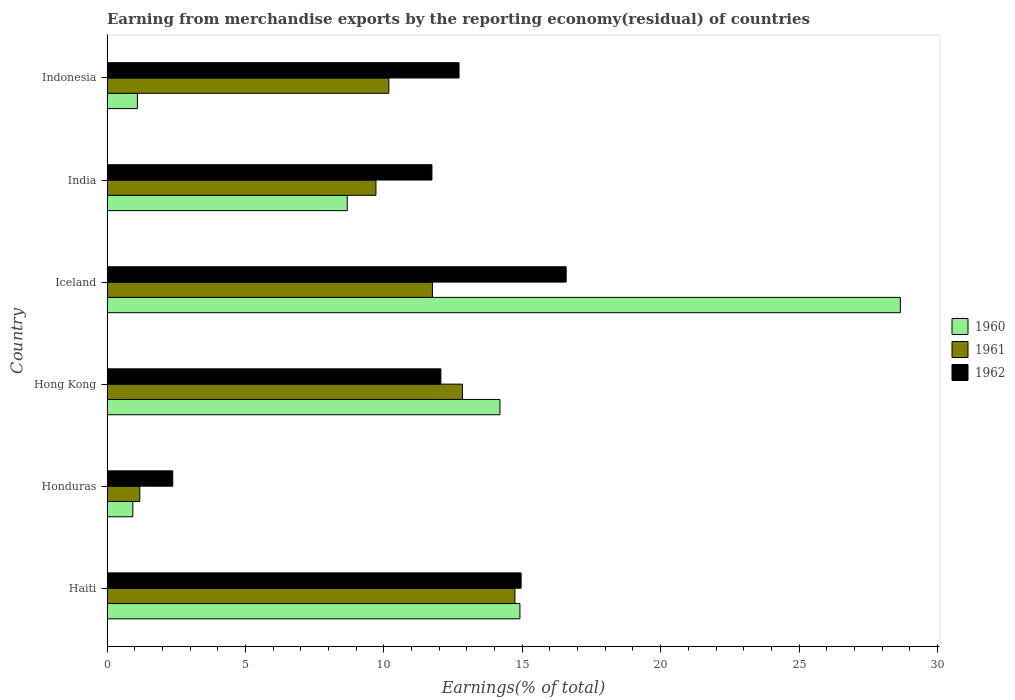How many different coloured bars are there?
Your answer should be compact. 3. Are the number of bars per tick equal to the number of legend labels?
Offer a very short reply. Yes. How many bars are there on the 2nd tick from the top?
Offer a very short reply. 3. How many bars are there on the 6th tick from the bottom?
Keep it short and to the point. 3. What is the label of the 1st group of bars from the top?
Provide a short and direct response. Indonesia. In how many cases, is the number of bars for a given country not equal to the number of legend labels?
Your answer should be very brief. 0. What is the percentage of amount earned from merchandise exports in 1961 in India?
Provide a short and direct response. 9.71. Across all countries, what is the maximum percentage of amount earned from merchandise exports in 1961?
Your answer should be very brief. 14.74. Across all countries, what is the minimum percentage of amount earned from merchandise exports in 1961?
Offer a very short reply. 1.19. In which country was the percentage of amount earned from merchandise exports in 1961 maximum?
Give a very brief answer. Haiti. In which country was the percentage of amount earned from merchandise exports in 1962 minimum?
Offer a terse response. Honduras. What is the total percentage of amount earned from merchandise exports in 1962 in the graph?
Your answer should be very brief. 70.44. What is the difference between the percentage of amount earned from merchandise exports in 1962 in Hong Kong and that in Iceland?
Offer a very short reply. -4.53. What is the difference between the percentage of amount earned from merchandise exports in 1960 in India and the percentage of amount earned from merchandise exports in 1962 in Honduras?
Provide a short and direct response. 6.3. What is the average percentage of amount earned from merchandise exports in 1961 per country?
Offer a terse response. 10.07. What is the difference between the percentage of amount earned from merchandise exports in 1961 and percentage of amount earned from merchandise exports in 1962 in Haiti?
Ensure brevity in your answer.  -0.22. In how many countries, is the percentage of amount earned from merchandise exports in 1961 greater than 27 %?
Offer a very short reply. 0. What is the ratio of the percentage of amount earned from merchandise exports in 1962 in Haiti to that in Indonesia?
Your answer should be compact. 1.18. Is the percentage of amount earned from merchandise exports in 1962 in Haiti less than that in Iceland?
Give a very brief answer. Yes. What is the difference between the highest and the second highest percentage of amount earned from merchandise exports in 1960?
Offer a terse response. 13.74. What is the difference between the highest and the lowest percentage of amount earned from merchandise exports in 1960?
Your answer should be compact. 27.73. Is the sum of the percentage of amount earned from merchandise exports in 1962 in Hong Kong and India greater than the maximum percentage of amount earned from merchandise exports in 1960 across all countries?
Provide a short and direct response. No. What does the 2nd bar from the top in Haiti represents?
Give a very brief answer. 1961. What does the 1st bar from the bottom in India represents?
Make the answer very short. 1960. Is it the case that in every country, the sum of the percentage of amount earned from merchandise exports in 1962 and percentage of amount earned from merchandise exports in 1960 is greater than the percentage of amount earned from merchandise exports in 1961?
Offer a very short reply. Yes. Are all the bars in the graph horizontal?
Offer a very short reply. Yes. How many countries are there in the graph?
Ensure brevity in your answer.  6. What is the difference between two consecutive major ticks on the X-axis?
Give a very brief answer. 5. Does the graph contain grids?
Offer a very short reply. No. Where does the legend appear in the graph?
Make the answer very short. Center right. How many legend labels are there?
Keep it short and to the point. 3. What is the title of the graph?
Make the answer very short. Earning from merchandise exports by the reporting economy(residual) of countries. What is the label or title of the X-axis?
Your answer should be compact. Earnings(% of total). What is the Earnings(% of total) in 1960 in Haiti?
Provide a short and direct response. 14.92. What is the Earnings(% of total) in 1961 in Haiti?
Ensure brevity in your answer.  14.74. What is the Earnings(% of total) in 1962 in Haiti?
Offer a very short reply. 14.96. What is the Earnings(% of total) in 1960 in Honduras?
Your answer should be very brief. 0.93. What is the Earnings(% of total) of 1961 in Honduras?
Your answer should be compact. 1.19. What is the Earnings(% of total) of 1962 in Honduras?
Offer a terse response. 2.38. What is the Earnings(% of total) of 1960 in Hong Kong?
Give a very brief answer. 14.2. What is the Earnings(% of total) in 1961 in Hong Kong?
Ensure brevity in your answer.  12.84. What is the Earnings(% of total) in 1962 in Hong Kong?
Offer a very short reply. 12.06. What is the Earnings(% of total) in 1960 in Iceland?
Make the answer very short. 28.66. What is the Earnings(% of total) of 1961 in Iceland?
Give a very brief answer. 11.76. What is the Earnings(% of total) in 1962 in Iceland?
Your answer should be very brief. 16.59. What is the Earnings(% of total) of 1960 in India?
Your answer should be very brief. 8.68. What is the Earnings(% of total) of 1961 in India?
Your answer should be compact. 9.71. What is the Earnings(% of total) of 1962 in India?
Provide a short and direct response. 11.74. What is the Earnings(% of total) in 1960 in Indonesia?
Your answer should be very brief. 1.1. What is the Earnings(% of total) in 1961 in Indonesia?
Your response must be concise. 10.18. What is the Earnings(% of total) in 1962 in Indonesia?
Your answer should be compact. 12.72. Across all countries, what is the maximum Earnings(% of total) in 1960?
Keep it short and to the point. 28.66. Across all countries, what is the maximum Earnings(% of total) of 1961?
Keep it short and to the point. 14.74. Across all countries, what is the maximum Earnings(% of total) in 1962?
Give a very brief answer. 16.59. Across all countries, what is the minimum Earnings(% of total) of 1960?
Make the answer very short. 0.93. Across all countries, what is the minimum Earnings(% of total) in 1961?
Keep it short and to the point. 1.19. Across all countries, what is the minimum Earnings(% of total) in 1962?
Provide a short and direct response. 2.38. What is the total Earnings(% of total) of 1960 in the graph?
Ensure brevity in your answer.  68.48. What is the total Earnings(% of total) in 1961 in the graph?
Your answer should be very brief. 60.42. What is the total Earnings(% of total) of 1962 in the graph?
Offer a very short reply. 70.44. What is the difference between the Earnings(% of total) in 1960 in Haiti and that in Honduras?
Offer a very short reply. 13.98. What is the difference between the Earnings(% of total) of 1961 in Haiti and that in Honduras?
Your response must be concise. 13.55. What is the difference between the Earnings(% of total) in 1962 in Haiti and that in Honduras?
Provide a succinct answer. 12.58. What is the difference between the Earnings(% of total) of 1960 in Haiti and that in Hong Kong?
Your answer should be very brief. 0.72. What is the difference between the Earnings(% of total) in 1961 in Haiti and that in Hong Kong?
Provide a short and direct response. 1.89. What is the difference between the Earnings(% of total) in 1962 in Haiti and that in Hong Kong?
Offer a very short reply. 2.9. What is the difference between the Earnings(% of total) in 1960 in Haiti and that in Iceland?
Keep it short and to the point. -13.74. What is the difference between the Earnings(% of total) of 1961 in Haiti and that in Iceland?
Ensure brevity in your answer.  2.98. What is the difference between the Earnings(% of total) of 1962 in Haiti and that in Iceland?
Provide a succinct answer. -1.63. What is the difference between the Earnings(% of total) in 1960 in Haiti and that in India?
Offer a very short reply. 6.24. What is the difference between the Earnings(% of total) in 1961 in Haiti and that in India?
Ensure brevity in your answer.  5.02. What is the difference between the Earnings(% of total) in 1962 in Haiti and that in India?
Ensure brevity in your answer.  3.22. What is the difference between the Earnings(% of total) of 1960 in Haiti and that in Indonesia?
Provide a succinct answer. 13.82. What is the difference between the Earnings(% of total) in 1961 in Haiti and that in Indonesia?
Offer a very short reply. 4.55. What is the difference between the Earnings(% of total) in 1962 in Haiti and that in Indonesia?
Your answer should be compact. 2.24. What is the difference between the Earnings(% of total) of 1960 in Honduras and that in Hong Kong?
Offer a terse response. -13.26. What is the difference between the Earnings(% of total) in 1961 in Honduras and that in Hong Kong?
Keep it short and to the point. -11.66. What is the difference between the Earnings(% of total) in 1962 in Honduras and that in Hong Kong?
Give a very brief answer. -9.69. What is the difference between the Earnings(% of total) in 1960 in Honduras and that in Iceland?
Provide a short and direct response. -27.73. What is the difference between the Earnings(% of total) of 1961 in Honduras and that in Iceland?
Offer a very short reply. -10.57. What is the difference between the Earnings(% of total) in 1962 in Honduras and that in Iceland?
Your answer should be compact. -14.21. What is the difference between the Earnings(% of total) of 1960 in Honduras and that in India?
Keep it short and to the point. -7.75. What is the difference between the Earnings(% of total) of 1961 in Honduras and that in India?
Provide a short and direct response. -8.53. What is the difference between the Earnings(% of total) in 1962 in Honduras and that in India?
Provide a short and direct response. -9.36. What is the difference between the Earnings(% of total) of 1960 in Honduras and that in Indonesia?
Ensure brevity in your answer.  -0.17. What is the difference between the Earnings(% of total) in 1961 in Honduras and that in Indonesia?
Your response must be concise. -9. What is the difference between the Earnings(% of total) of 1962 in Honduras and that in Indonesia?
Your answer should be compact. -10.34. What is the difference between the Earnings(% of total) of 1960 in Hong Kong and that in Iceland?
Your response must be concise. -14.46. What is the difference between the Earnings(% of total) of 1961 in Hong Kong and that in Iceland?
Offer a terse response. 1.09. What is the difference between the Earnings(% of total) of 1962 in Hong Kong and that in Iceland?
Your answer should be compact. -4.53. What is the difference between the Earnings(% of total) of 1960 in Hong Kong and that in India?
Make the answer very short. 5.52. What is the difference between the Earnings(% of total) of 1961 in Hong Kong and that in India?
Offer a terse response. 3.13. What is the difference between the Earnings(% of total) in 1962 in Hong Kong and that in India?
Ensure brevity in your answer.  0.32. What is the difference between the Earnings(% of total) of 1960 in Hong Kong and that in Indonesia?
Your answer should be very brief. 13.1. What is the difference between the Earnings(% of total) of 1961 in Hong Kong and that in Indonesia?
Your answer should be compact. 2.66. What is the difference between the Earnings(% of total) of 1962 in Hong Kong and that in Indonesia?
Ensure brevity in your answer.  -0.66. What is the difference between the Earnings(% of total) in 1960 in Iceland and that in India?
Give a very brief answer. 19.98. What is the difference between the Earnings(% of total) in 1961 in Iceland and that in India?
Your response must be concise. 2.04. What is the difference between the Earnings(% of total) of 1962 in Iceland and that in India?
Your answer should be very brief. 4.85. What is the difference between the Earnings(% of total) of 1960 in Iceland and that in Indonesia?
Your answer should be compact. 27.56. What is the difference between the Earnings(% of total) of 1961 in Iceland and that in Indonesia?
Give a very brief answer. 1.57. What is the difference between the Earnings(% of total) in 1962 in Iceland and that in Indonesia?
Offer a very short reply. 3.87. What is the difference between the Earnings(% of total) of 1960 in India and that in Indonesia?
Your response must be concise. 7.58. What is the difference between the Earnings(% of total) in 1961 in India and that in Indonesia?
Your answer should be compact. -0.47. What is the difference between the Earnings(% of total) of 1962 in India and that in Indonesia?
Make the answer very short. -0.98. What is the difference between the Earnings(% of total) in 1960 in Haiti and the Earnings(% of total) in 1961 in Honduras?
Provide a succinct answer. 13.73. What is the difference between the Earnings(% of total) in 1960 in Haiti and the Earnings(% of total) in 1962 in Honduras?
Make the answer very short. 12.54. What is the difference between the Earnings(% of total) in 1961 in Haiti and the Earnings(% of total) in 1962 in Honduras?
Provide a succinct answer. 12.36. What is the difference between the Earnings(% of total) of 1960 in Haiti and the Earnings(% of total) of 1961 in Hong Kong?
Your answer should be very brief. 2.08. What is the difference between the Earnings(% of total) of 1960 in Haiti and the Earnings(% of total) of 1962 in Hong Kong?
Provide a succinct answer. 2.86. What is the difference between the Earnings(% of total) in 1961 in Haiti and the Earnings(% of total) in 1962 in Hong Kong?
Make the answer very short. 2.67. What is the difference between the Earnings(% of total) of 1960 in Haiti and the Earnings(% of total) of 1961 in Iceland?
Ensure brevity in your answer.  3.16. What is the difference between the Earnings(% of total) in 1960 in Haiti and the Earnings(% of total) in 1962 in Iceland?
Provide a short and direct response. -1.67. What is the difference between the Earnings(% of total) of 1961 in Haiti and the Earnings(% of total) of 1962 in Iceland?
Give a very brief answer. -1.85. What is the difference between the Earnings(% of total) of 1960 in Haiti and the Earnings(% of total) of 1961 in India?
Your answer should be compact. 5.2. What is the difference between the Earnings(% of total) in 1960 in Haiti and the Earnings(% of total) in 1962 in India?
Provide a short and direct response. 3.18. What is the difference between the Earnings(% of total) of 1961 in Haiti and the Earnings(% of total) of 1962 in India?
Ensure brevity in your answer.  3. What is the difference between the Earnings(% of total) in 1960 in Haiti and the Earnings(% of total) in 1961 in Indonesia?
Provide a succinct answer. 4.74. What is the difference between the Earnings(% of total) of 1960 in Haiti and the Earnings(% of total) of 1962 in Indonesia?
Provide a short and direct response. 2.2. What is the difference between the Earnings(% of total) in 1961 in Haiti and the Earnings(% of total) in 1962 in Indonesia?
Offer a terse response. 2.02. What is the difference between the Earnings(% of total) of 1960 in Honduras and the Earnings(% of total) of 1961 in Hong Kong?
Give a very brief answer. -11.91. What is the difference between the Earnings(% of total) in 1960 in Honduras and the Earnings(% of total) in 1962 in Hong Kong?
Your answer should be very brief. -11.13. What is the difference between the Earnings(% of total) of 1961 in Honduras and the Earnings(% of total) of 1962 in Hong Kong?
Offer a terse response. -10.88. What is the difference between the Earnings(% of total) of 1960 in Honduras and the Earnings(% of total) of 1961 in Iceland?
Your response must be concise. -10.82. What is the difference between the Earnings(% of total) in 1960 in Honduras and the Earnings(% of total) in 1962 in Iceland?
Your answer should be very brief. -15.65. What is the difference between the Earnings(% of total) in 1961 in Honduras and the Earnings(% of total) in 1962 in Iceland?
Give a very brief answer. -15.4. What is the difference between the Earnings(% of total) of 1960 in Honduras and the Earnings(% of total) of 1961 in India?
Give a very brief answer. -8.78. What is the difference between the Earnings(% of total) of 1960 in Honduras and the Earnings(% of total) of 1962 in India?
Keep it short and to the point. -10.8. What is the difference between the Earnings(% of total) of 1961 in Honduras and the Earnings(% of total) of 1962 in India?
Give a very brief answer. -10.55. What is the difference between the Earnings(% of total) of 1960 in Honduras and the Earnings(% of total) of 1961 in Indonesia?
Provide a succinct answer. -9.25. What is the difference between the Earnings(% of total) of 1960 in Honduras and the Earnings(% of total) of 1962 in Indonesia?
Your answer should be compact. -11.78. What is the difference between the Earnings(% of total) in 1961 in Honduras and the Earnings(% of total) in 1962 in Indonesia?
Make the answer very short. -11.53. What is the difference between the Earnings(% of total) in 1960 in Hong Kong and the Earnings(% of total) in 1961 in Iceland?
Your answer should be compact. 2.44. What is the difference between the Earnings(% of total) in 1960 in Hong Kong and the Earnings(% of total) in 1962 in Iceland?
Provide a short and direct response. -2.39. What is the difference between the Earnings(% of total) in 1961 in Hong Kong and the Earnings(% of total) in 1962 in Iceland?
Keep it short and to the point. -3.75. What is the difference between the Earnings(% of total) of 1960 in Hong Kong and the Earnings(% of total) of 1961 in India?
Offer a terse response. 4.48. What is the difference between the Earnings(% of total) in 1960 in Hong Kong and the Earnings(% of total) in 1962 in India?
Ensure brevity in your answer.  2.46. What is the difference between the Earnings(% of total) in 1961 in Hong Kong and the Earnings(% of total) in 1962 in India?
Ensure brevity in your answer.  1.1. What is the difference between the Earnings(% of total) of 1960 in Hong Kong and the Earnings(% of total) of 1961 in Indonesia?
Offer a terse response. 4.01. What is the difference between the Earnings(% of total) of 1960 in Hong Kong and the Earnings(% of total) of 1962 in Indonesia?
Offer a very short reply. 1.48. What is the difference between the Earnings(% of total) in 1961 in Hong Kong and the Earnings(% of total) in 1962 in Indonesia?
Provide a succinct answer. 0.12. What is the difference between the Earnings(% of total) in 1960 in Iceland and the Earnings(% of total) in 1961 in India?
Provide a short and direct response. 18.94. What is the difference between the Earnings(% of total) in 1960 in Iceland and the Earnings(% of total) in 1962 in India?
Your answer should be very brief. 16.92. What is the difference between the Earnings(% of total) of 1961 in Iceland and the Earnings(% of total) of 1962 in India?
Offer a terse response. 0.02. What is the difference between the Earnings(% of total) in 1960 in Iceland and the Earnings(% of total) in 1961 in Indonesia?
Your answer should be very brief. 18.48. What is the difference between the Earnings(% of total) in 1960 in Iceland and the Earnings(% of total) in 1962 in Indonesia?
Provide a short and direct response. 15.94. What is the difference between the Earnings(% of total) in 1961 in Iceland and the Earnings(% of total) in 1962 in Indonesia?
Provide a succinct answer. -0.96. What is the difference between the Earnings(% of total) of 1960 in India and the Earnings(% of total) of 1961 in Indonesia?
Ensure brevity in your answer.  -1.5. What is the difference between the Earnings(% of total) of 1960 in India and the Earnings(% of total) of 1962 in Indonesia?
Provide a short and direct response. -4.04. What is the difference between the Earnings(% of total) in 1961 in India and the Earnings(% of total) in 1962 in Indonesia?
Provide a short and direct response. -3. What is the average Earnings(% of total) of 1960 per country?
Make the answer very short. 11.41. What is the average Earnings(% of total) in 1961 per country?
Your answer should be compact. 10.07. What is the average Earnings(% of total) of 1962 per country?
Make the answer very short. 11.74. What is the difference between the Earnings(% of total) of 1960 and Earnings(% of total) of 1961 in Haiti?
Provide a succinct answer. 0.18. What is the difference between the Earnings(% of total) of 1960 and Earnings(% of total) of 1962 in Haiti?
Give a very brief answer. -0.04. What is the difference between the Earnings(% of total) in 1961 and Earnings(% of total) in 1962 in Haiti?
Your answer should be very brief. -0.22. What is the difference between the Earnings(% of total) in 1960 and Earnings(% of total) in 1961 in Honduras?
Make the answer very short. -0.25. What is the difference between the Earnings(% of total) in 1960 and Earnings(% of total) in 1962 in Honduras?
Offer a very short reply. -1.44. What is the difference between the Earnings(% of total) of 1961 and Earnings(% of total) of 1962 in Honduras?
Give a very brief answer. -1.19. What is the difference between the Earnings(% of total) of 1960 and Earnings(% of total) of 1961 in Hong Kong?
Your answer should be compact. 1.35. What is the difference between the Earnings(% of total) of 1960 and Earnings(% of total) of 1962 in Hong Kong?
Ensure brevity in your answer.  2.13. What is the difference between the Earnings(% of total) of 1961 and Earnings(% of total) of 1962 in Hong Kong?
Offer a very short reply. 0.78. What is the difference between the Earnings(% of total) of 1960 and Earnings(% of total) of 1961 in Iceland?
Your answer should be compact. 16.9. What is the difference between the Earnings(% of total) in 1960 and Earnings(% of total) in 1962 in Iceland?
Offer a very short reply. 12.07. What is the difference between the Earnings(% of total) of 1961 and Earnings(% of total) of 1962 in Iceland?
Make the answer very short. -4.83. What is the difference between the Earnings(% of total) of 1960 and Earnings(% of total) of 1961 in India?
Your answer should be very brief. -1.04. What is the difference between the Earnings(% of total) of 1960 and Earnings(% of total) of 1962 in India?
Provide a short and direct response. -3.06. What is the difference between the Earnings(% of total) of 1961 and Earnings(% of total) of 1962 in India?
Make the answer very short. -2.02. What is the difference between the Earnings(% of total) of 1960 and Earnings(% of total) of 1961 in Indonesia?
Offer a terse response. -9.08. What is the difference between the Earnings(% of total) in 1960 and Earnings(% of total) in 1962 in Indonesia?
Your answer should be compact. -11.62. What is the difference between the Earnings(% of total) in 1961 and Earnings(% of total) in 1962 in Indonesia?
Provide a succinct answer. -2.54. What is the ratio of the Earnings(% of total) in 1960 in Haiti to that in Honduras?
Offer a terse response. 15.99. What is the ratio of the Earnings(% of total) of 1961 in Haiti to that in Honduras?
Make the answer very short. 12.43. What is the ratio of the Earnings(% of total) in 1962 in Haiti to that in Honduras?
Keep it short and to the point. 6.3. What is the ratio of the Earnings(% of total) of 1960 in Haiti to that in Hong Kong?
Provide a succinct answer. 1.05. What is the ratio of the Earnings(% of total) of 1961 in Haiti to that in Hong Kong?
Make the answer very short. 1.15. What is the ratio of the Earnings(% of total) in 1962 in Haiti to that in Hong Kong?
Give a very brief answer. 1.24. What is the ratio of the Earnings(% of total) in 1960 in Haiti to that in Iceland?
Provide a short and direct response. 0.52. What is the ratio of the Earnings(% of total) of 1961 in Haiti to that in Iceland?
Give a very brief answer. 1.25. What is the ratio of the Earnings(% of total) in 1962 in Haiti to that in Iceland?
Offer a very short reply. 0.9. What is the ratio of the Earnings(% of total) of 1960 in Haiti to that in India?
Provide a succinct answer. 1.72. What is the ratio of the Earnings(% of total) in 1961 in Haiti to that in India?
Make the answer very short. 1.52. What is the ratio of the Earnings(% of total) of 1962 in Haiti to that in India?
Give a very brief answer. 1.27. What is the ratio of the Earnings(% of total) in 1960 in Haiti to that in Indonesia?
Provide a short and direct response. 13.57. What is the ratio of the Earnings(% of total) of 1961 in Haiti to that in Indonesia?
Provide a succinct answer. 1.45. What is the ratio of the Earnings(% of total) of 1962 in Haiti to that in Indonesia?
Ensure brevity in your answer.  1.18. What is the ratio of the Earnings(% of total) in 1960 in Honduras to that in Hong Kong?
Your answer should be compact. 0.07. What is the ratio of the Earnings(% of total) of 1961 in Honduras to that in Hong Kong?
Your response must be concise. 0.09. What is the ratio of the Earnings(% of total) in 1962 in Honduras to that in Hong Kong?
Ensure brevity in your answer.  0.2. What is the ratio of the Earnings(% of total) of 1960 in Honduras to that in Iceland?
Your answer should be very brief. 0.03. What is the ratio of the Earnings(% of total) in 1961 in Honduras to that in Iceland?
Keep it short and to the point. 0.1. What is the ratio of the Earnings(% of total) of 1962 in Honduras to that in Iceland?
Provide a short and direct response. 0.14. What is the ratio of the Earnings(% of total) of 1960 in Honduras to that in India?
Provide a short and direct response. 0.11. What is the ratio of the Earnings(% of total) of 1961 in Honduras to that in India?
Provide a succinct answer. 0.12. What is the ratio of the Earnings(% of total) in 1962 in Honduras to that in India?
Offer a terse response. 0.2. What is the ratio of the Earnings(% of total) of 1960 in Honduras to that in Indonesia?
Provide a short and direct response. 0.85. What is the ratio of the Earnings(% of total) in 1961 in Honduras to that in Indonesia?
Your answer should be very brief. 0.12. What is the ratio of the Earnings(% of total) in 1962 in Honduras to that in Indonesia?
Provide a short and direct response. 0.19. What is the ratio of the Earnings(% of total) of 1960 in Hong Kong to that in Iceland?
Provide a succinct answer. 0.5. What is the ratio of the Earnings(% of total) of 1961 in Hong Kong to that in Iceland?
Make the answer very short. 1.09. What is the ratio of the Earnings(% of total) in 1962 in Hong Kong to that in Iceland?
Your answer should be very brief. 0.73. What is the ratio of the Earnings(% of total) in 1960 in Hong Kong to that in India?
Make the answer very short. 1.64. What is the ratio of the Earnings(% of total) of 1961 in Hong Kong to that in India?
Your response must be concise. 1.32. What is the ratio of the Earnings(% of total) in 1962 in Hong Kong to that in India?
Provide a short and direct response. 1.03. What is the ratio of the Earnings(% of total) of 1960 in Hong Kong to that in Indonesia?
Provide a short and direct response. 12.92. What is the ratio of the Earnings(% of total) in 1961 in Hong Kong to that in Indonesia?
Provide a short and direct response. 1.26. What is the ratio of the Earnings(% of total) of 1962 in Hong Kong to that in Indonesia?
Your response must be concise. 0.95. What is the ratio of the Earnings(% of total) of 1960 in Iceland to that in India?
Keep it short and to the point. 3.3. What is the ratio of the Earnings(% of total) in 1961 in Iceland to that in India?
Your answer should be compact. 1.21. What is the ratio of the Earnings(% of total) in 1962 in Iceland to that in India?
Offer a very short reply. 1.41. What is the ratio of the Earnings(% of total) of 1960 in Iceland to that in Indonesia?
Your response must be concise. 26.08. What is the ratio of the Earnings(% of total) of 1961 in Iceland to that in Indonesia?
Your response must be concise. 1.15. What is the ratio of the Earnings(% of total) of 1962 in Iceland to that in Indonesia?
Your answer should be compact. 1.3. What is the ratio of the Earnings(% of total) in 1960 in India to that in Indonesia?
Make the answer very short. 7.9. What is the ratio of the Earnings(% of total) of 1961 in India to that in Indonesia?
Keep it short and to the point. 0.95. What is the ratio of the Earnings(% of total) in 1962 in India to that in Indonesia?
Provide a succinct answer. 0.92. What is the difference between the highest and the second highest Earnings(% of total) of 1960?
Make the answer very short. 13.74. What is the difference between the highest and the second highest Earnings(% of total) in 1961?
Ensure brevity in your answer.  1.89. What is the difference between the highest and the second highest Earnings(% of total) of 1962?
Your response must be concise. 1.63. What is the difference between the highest and the lowest Earnings(% of total) in 1960?
Keep it short and to the point. 27.73. What is the difference between the highest and the lowest Earnings(% of total) in 1961?
Ensure brevity in your answer.  13.55. What is the difference between the highest and the lowest Earnings(% of total) in 1962?
Ensure brevity in your answer.  14.21. 